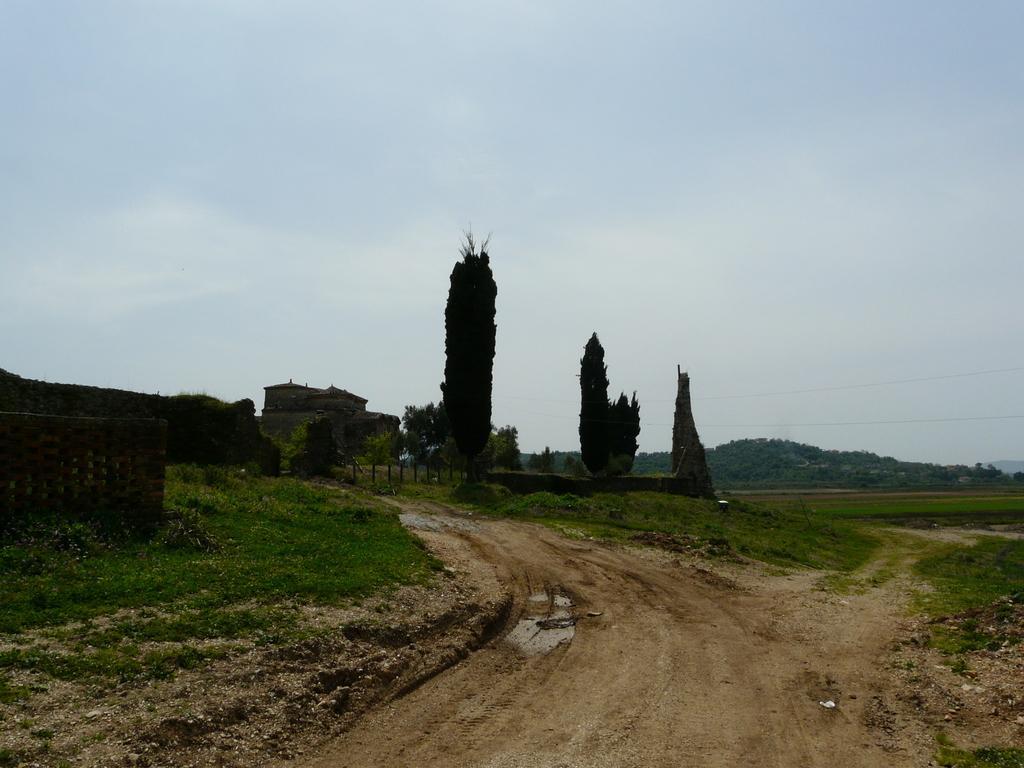Could you give a brief overview of what you see in this image? In the image there is a sand road and around that there is a lot of grass, a house and in the background there is a mountain. 